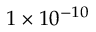Convert formula to latex. <formula><loc_0><loc_0><loc_500><loc_500>1 \times 1 0 ^ { - 1 0 }</formula> 